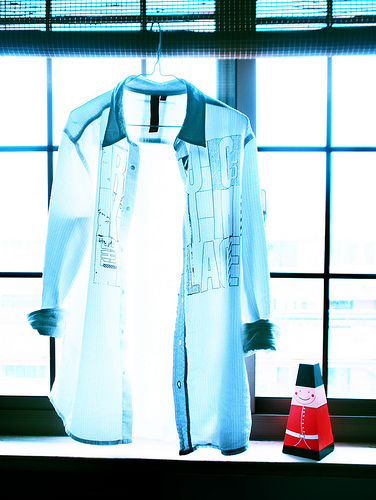<image>
Can you confirm if the shirt is in front of the window? Yes. The shirt is positioned in front of the window, appearing closer to the camera viewpoint. 